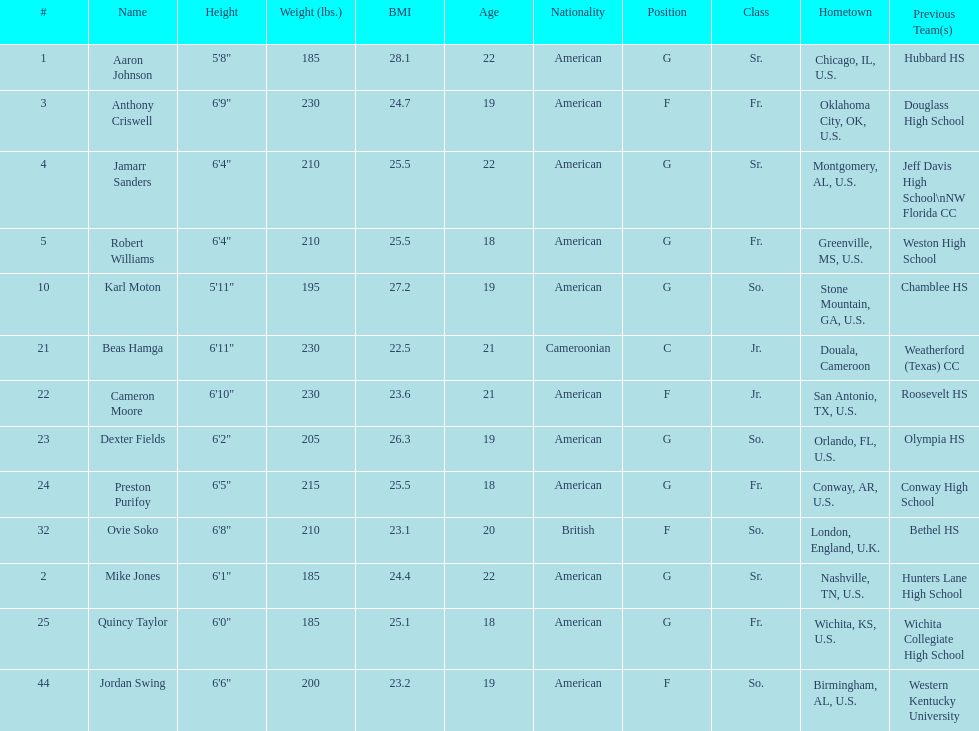Who weighs more, dexter fields or ovie soko? Ovie Soko. 